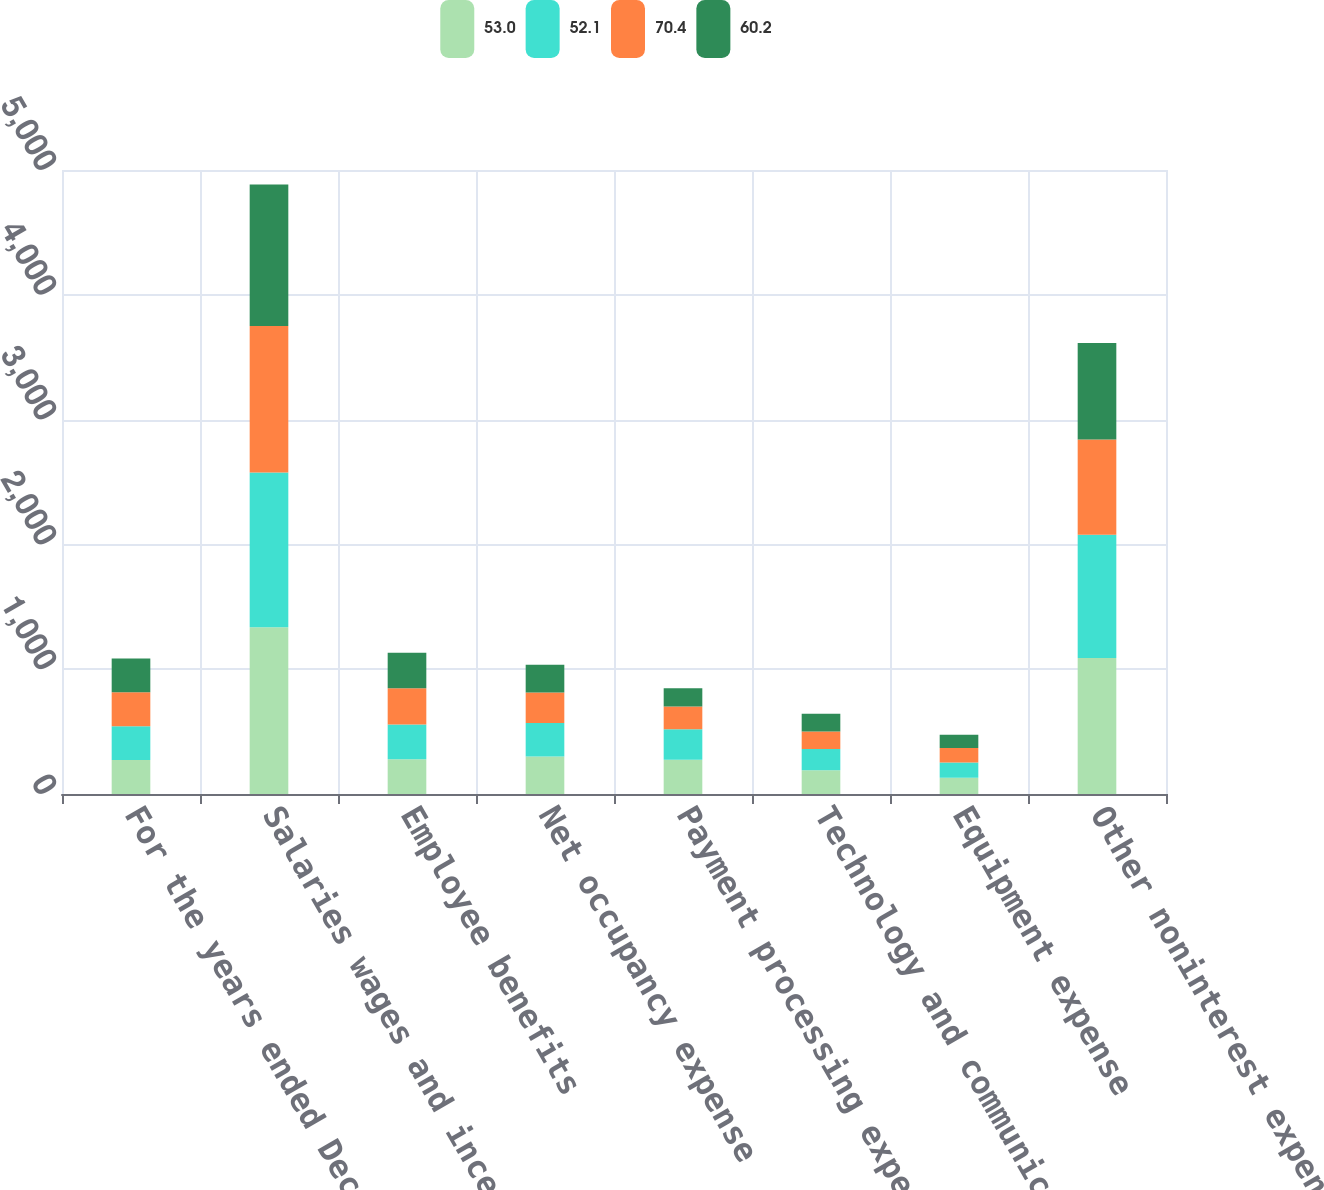Convert chart. <chart><loc_0><loc_0><loc_500><loc_500><stacked_bar_chart><ecel><fcel>For the years ended December<fcel>Salaries wages and incentives<fcel>Employee benefits<fcel>Net occupancy expense<fcel>Payment processing expense<fcel>Technology and communications<fcel>Equipment expense<fcel>Other noninterest expense<nl><fcel>53<fcel>271.5<fcel>1337<fcel>278<fcel>300<fcel>274<fcel>191<fcel>130<fcel>1089<nl><fcel>52.1<fcel>271.5<fcel>1239<fcel>278<fcel>269<fcel>244<fcel>169<fcel>123<fcel>989<nl><fcel>70.4<fcel>271.5<fcel>1174<fcel>292<fcel>245<fcel>184<fcel>141<fcel>116<fcel>763<nl><fcel>60.2<fcel>271.5<fcel>1133<fcel>283<fcel>221<fcel>145<fcel>142<fcel>105<fcel>772<nl></chart> 